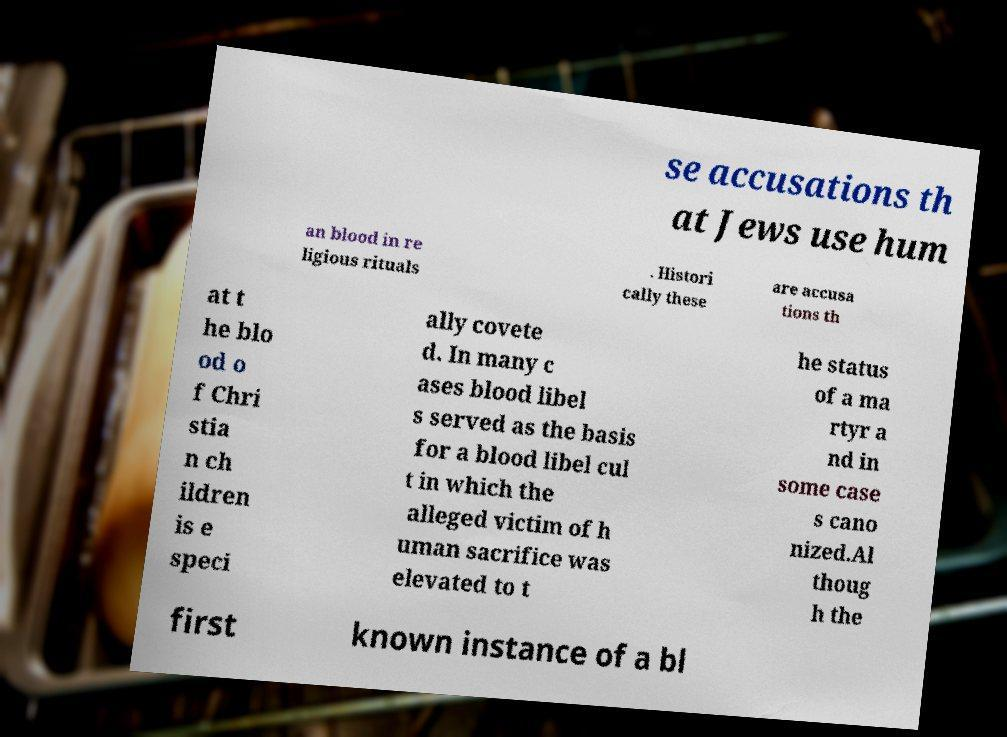Please read and relay the text visible in this image. What does it say? se accusations th at Jews use hum an blood in re ligious rituals . Histori cally these are accusa tions th at t he blo od o f Chri stia n ch ildren is e speci ally covete d. In many c ases blood libel s served as the basis for a blood libel cul t in which the alleged victim of h uman sacrifice was elevated to t he status of a ma rtyr a nd in some case s cano nized.Al thoug h the first known instance of a bl 